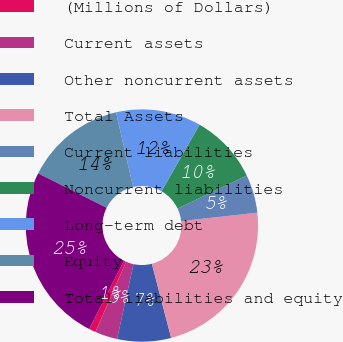Convert chart to OTSL. <chart><loc_0><loc_0><loc_500><loc_500><pie_chart><fcel>(Millions of Dollars)<fcel>Current assets<fcel>Other noncurrent assets<fcel>Total Assets<fcel>Current liabilities<fcel>Noncurrent liabilities<fcel>Long-term debt<fcel>Equity<fcel>Total liabilities and equity<nl><fcel>0.95%<fcel>3.13%<fcel>7.48%<fcel>22.72%<fcel>5.31%<fcel>9.66%<fcel>11.84%<fcel>14.01%<fcel>24.9%<nl></chart> 